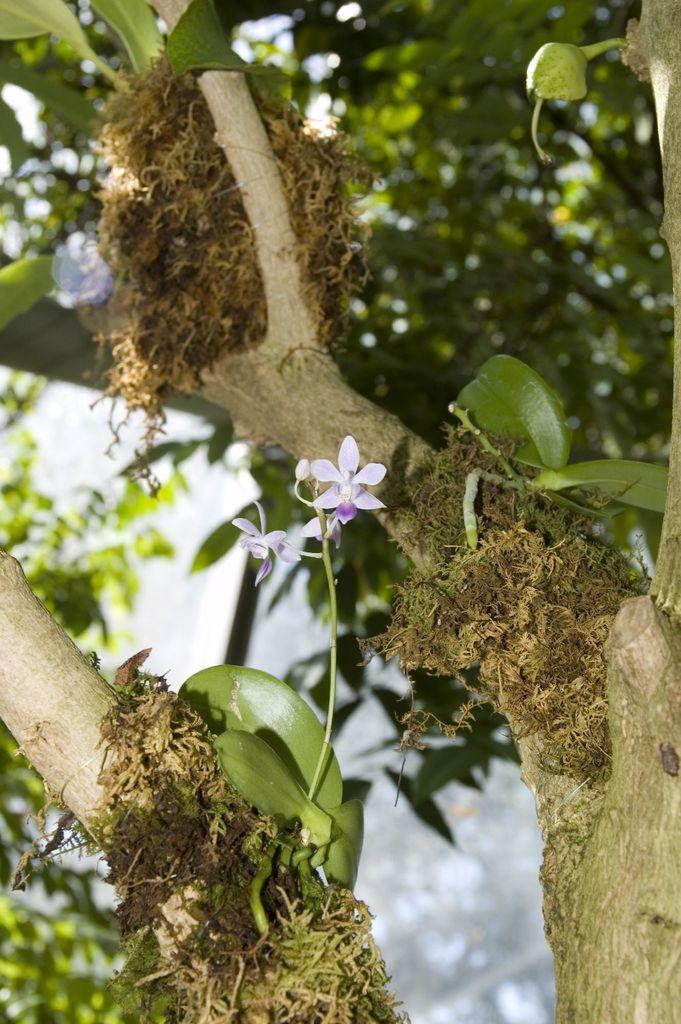What type of plants can be seen in the image? There are flowers and buds in the image. What type of plant is larger and more prominent in the image? There is a tree in the image. How would you describe the background of the image? The background of the image is blurred. What type of nerve is visible in the image? There is no nerve present in the image; it features flowers, buds, and a tree. What type of feast is being prepared in the image? There is no feast preparation visible in the image; it only shows plants and a blurred background. 